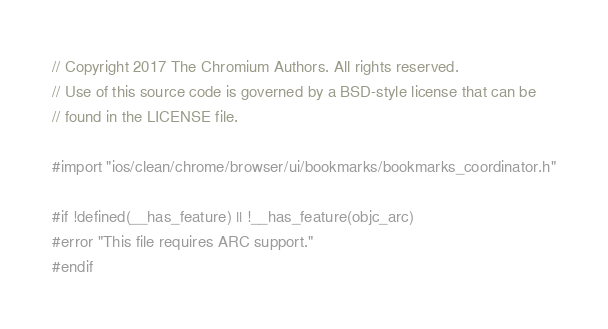<code> <loc_0><loc_0><loc_500><loc_500><_ObjectiveC_>// Copyright 2017 The Chromium Authors. All rights reserved.
// Use of this source code is governed by a BSD-style license that can be
// found in the LICENSE file.

#import "ios/clean/chrome/browser/ui/bookmarks/bookmarks_coordinator.h"

#if !defined(__has_feature) || !__has_feature(objc_arc)
#error "This file requires ARC support."
#endif
</code> 